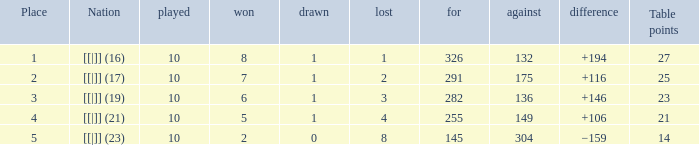For a +194 deficit, how many points are recorded in the table? 1.0. 